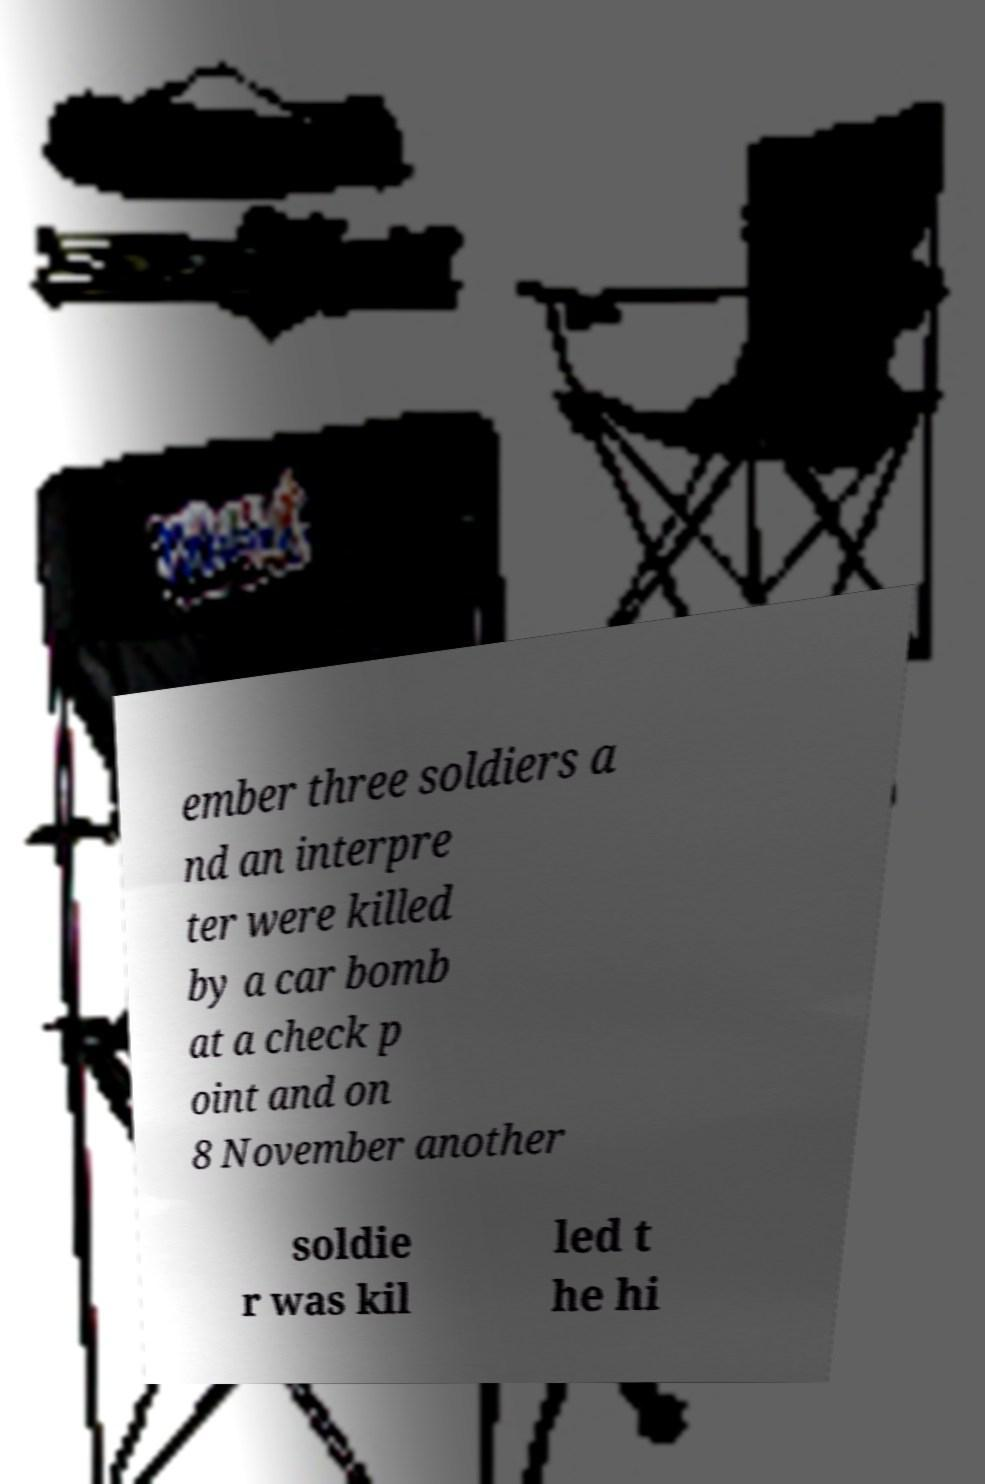Please identify and transcribe the text found in this image. ember three soldiers a nd an interpre ter were killed by a car bomb at a check p oint and on 8 November another soldie r was kil led t he hi 